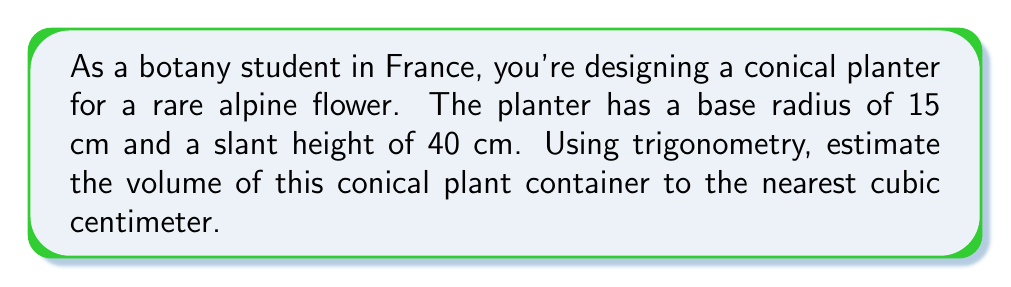What is the answer to this math problem? To solve this problem, we'll use trigonometry to find the height of the cone and then apply the formula for the volume of a cone. Let's break it down step-by-step:

1. Visualize the cone:
[asy]
import geometry;

size(200);
pair A = (0,0), B = (3,0), C = (0,8);
draw(A--B--C--A);
draw(B--(3,8),dashed);
label("15 cm",B,(1,-0.5),S);
label("40 cm",(1.5,4),E);
label("h",(-0.5,4),W);
label("r",(1.5,0),S);
[/asy]

2. In the right triangle formed by the radius, height, and slant height:
   - The radius (r) is 15 cm
   - The slant height (s) is 40 cm
   - We need to find the height (h)

3. Using the Pythagorean theorem:
   $$r^2 + h^2 = s^2$$
   $$15^2 + h^2 = 40^2$$
   $$225 + h^2 = 1600$$
   $$h^2 = 1375$$
   $$h = \sqrt{1375} \approx 37.08 \text{ cm}$$

4. Now that we have the height, we can use the formula for the volume of a cone:
   $$V = \frac{1}{3}\pi r^2 h$$

5. Substituting the values:
   $$V = \frac{1}{3}\pi (15\text{ cm})^2 (37.08\text{ cm})$$
   $$V = \frac{1}{3}\pi (225\text{ cm}^2) (37.08\text{ cm})$$
   $$V = 2778\pi \text{ cm}^3$$
   $$V \approx 8728.71 \text{ cm}^3$$

6. Rounding to the nearest cubic centimeter:
   $$V \approx 8729 \text{ cm}^3$$
Answer: The estimated volume of the conical plant container is approximately 8729 cm³. 